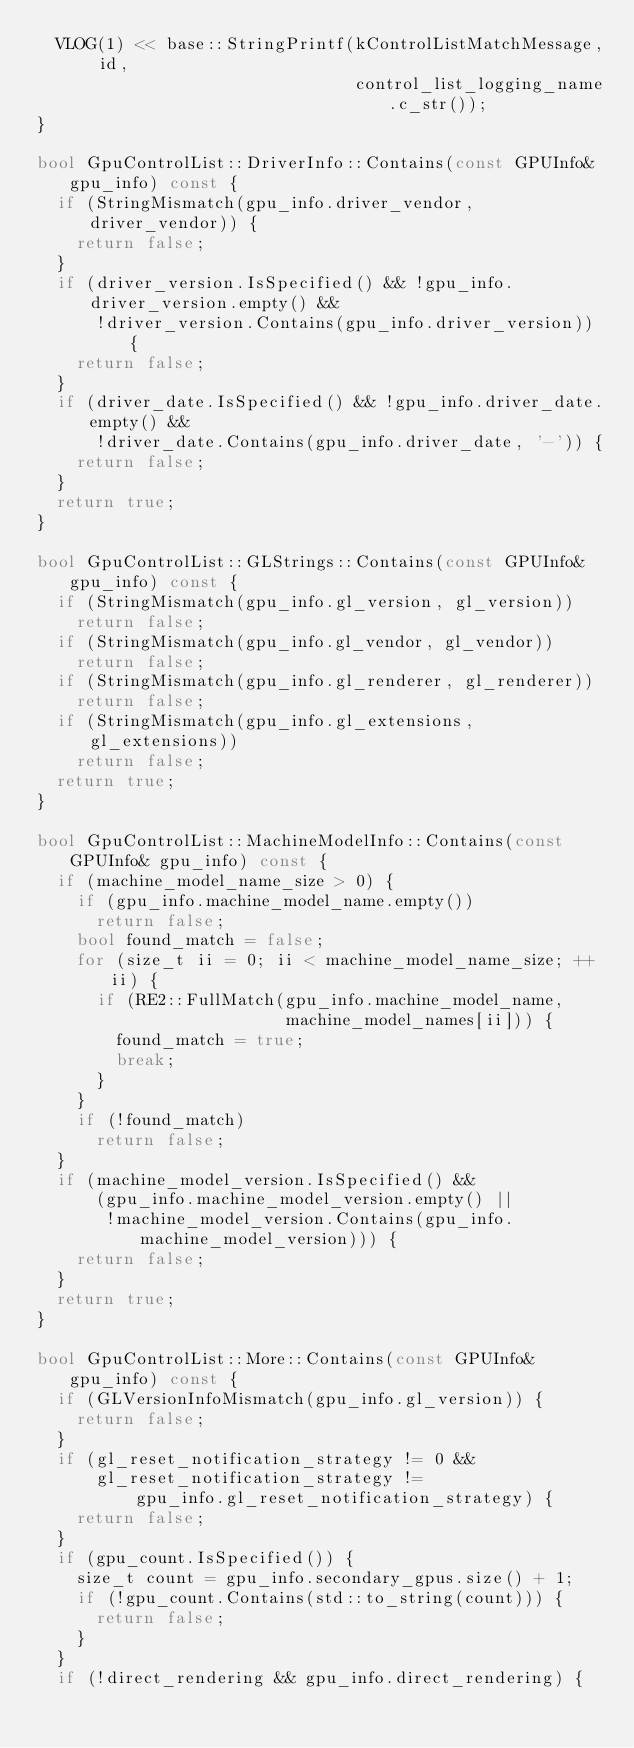Convert code to text. <code><loc_0><loc_0><loc_500><loc_500><_C++_>  VLOG(1) << base::StringPrintf(kControlListMatchMessage, id,
                                control_list_logging_name.c_str());
}

bool GpuControlList::DriverInfo::Contains(const GPUInfo& gpu_info) const {
  if (StringMismatch(gpu_info.driver_vendor, driver_vendor)) {
    return false;
  }
  if (driver_version.IsSpecified() && !gpu_info.driver_version.empty() &&
      !driver_version.Contains(gpu_info.driver_version)) {
    return false;
  }
  if (driver_date.IsSpecified() && !gpu_info.driver_date.empty() &&
      !driver_date.Contains(gpu_info.driver_date, '-')) {
    return false;
  }
  return true;
}

bool GpuControlList::GLStrings::Contains(const GPUInfo& gpu_info) const {
  if (StringMismatch(gpu_info.gl_version, gl_version))
    return false;
  if (StringMismatch(gpu_info.gl_vendor, gl_vendor))
    return false;
  if (StringMismatch(gpu_info.gl_renderer, gl_renderer))
    return false;
  if (StringMismatch(gpu_info.gl_extensions, gl_extensions))
    return false;
  return true;
}

bool GpuControlList::MachineModelInfo::Contains(const GPUInfo& gpu_info) const {
  if (machine_model_name_size > 0) {
    if (gpu_info.machine_model_name.empty())
      return false;
    bool found_match = false;
    for (size_t ii = 0; ii < machine_model_name_size; ++ii) {
      if (RE2::FullMatch(gpu_info.machine_model_name,
                         machine_model_names[ii])) {
        found_match = true;
        break;
      }
    }
    if (!found_match)
      return false;
  }
  if (machine_model_version.IsSpecified() &&
      (gpu_info.machine_model_version.empty() ||
       !machine_model_version.Contains(gpu_info.machine_model_version))) {
    return false;
  }
  return true;
}

bool GpuControlList::More::Contains(const GPUInfo& gpu_info) const {
  if (GLVersionInfoMismatch(gpu_info.gl_version)) {
    return false;
  }
  if (gl_reset_notification_strategy != 0 &&
      gl_reset_notification_strategy !=
          gpu_info.gl_reset_notification_strategy) {
    return false;
  }
  if (gpu_count.IsSpecified()) {
    size_t count = gpu_info.secondary_gpus.size() + 1;
    if (!gpu_count.Contains(std::to_string(count))) {
      return false;
    }
  }
  if (!direct_rendering && gpu_info.direct_rendering) {</code> 